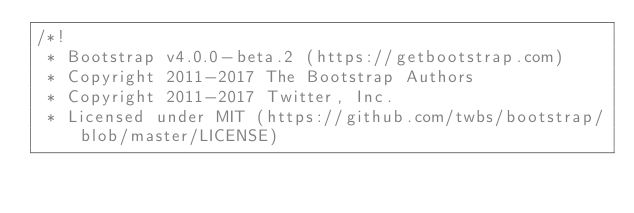Convert code to text. <code><loc_0><loc_0><loc_500><loc_500><_CSS_>/*!
 * Bootstrap v4.0.0-beta.2 (https://getbootstrap.com)
 * Copyright 2011-2017 The Bootstrap Authors
 * Copyright 2011-2017 Twitter, Inc.
 * Licensed under MIT (https://github.com/twbs/bootstrap/blob/master/LICENSE)</code> 